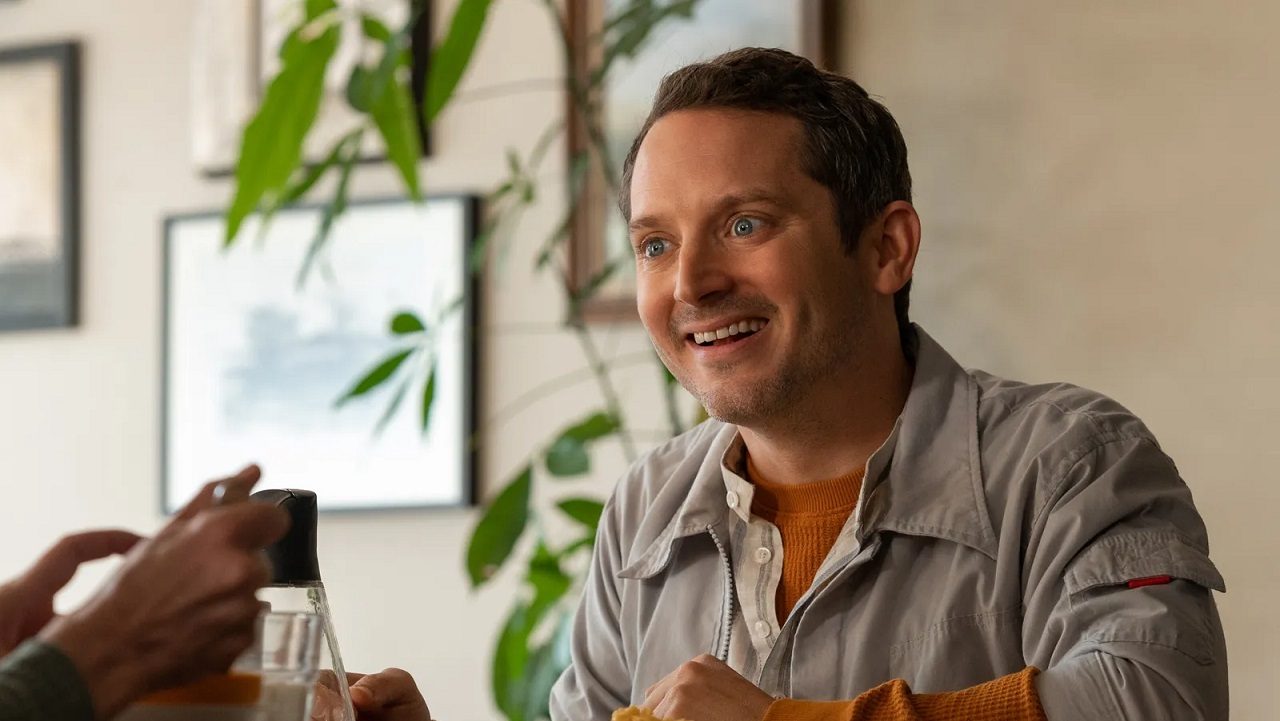What might be the background story of the person in this image? The person in the image could be someone who has recently achieved a personal milestone, like completing a challenging project or reuniting with an old friend. This moment shows him taking a well-deserved break in a favorite local spot, sharing stories and laughs. He could be a creative professional, an artist, or a writer, finding inspiration and joy in everyday life, reflected in his warm and engaging demeanor. His love for nature, seen in the background plants, might indicate he values balance and tranquility in his surroundings. 